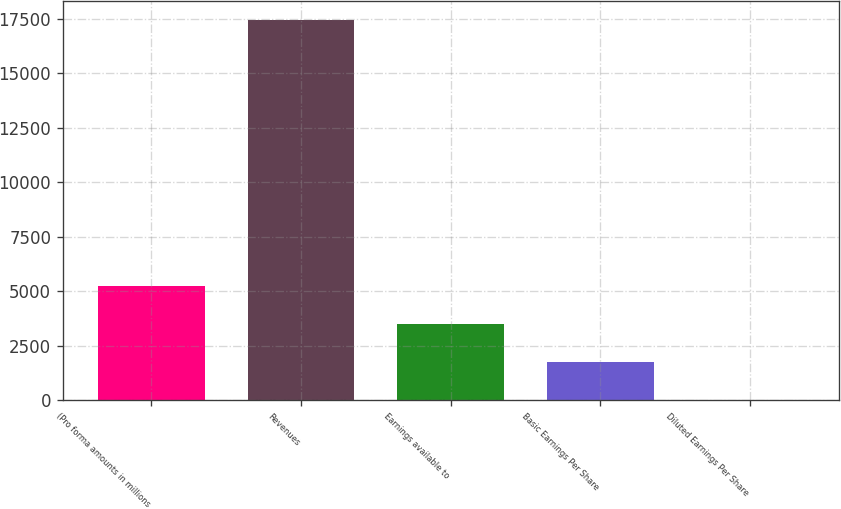Convert chart. <chart><loc_0><loc_0><loc_500><loc_500><bar_chart><fcel>(Pro forma amounts in millions<fcel>Revenues<fcel>Earnings available to<fcel>Basic Earnings Per Share<fcel>Diluted Earnings Per Share<nl><fcel>5236.34<fcel>17449<fcel>3491.67<fcel>1747<fcel>2.33<nl></chart> 